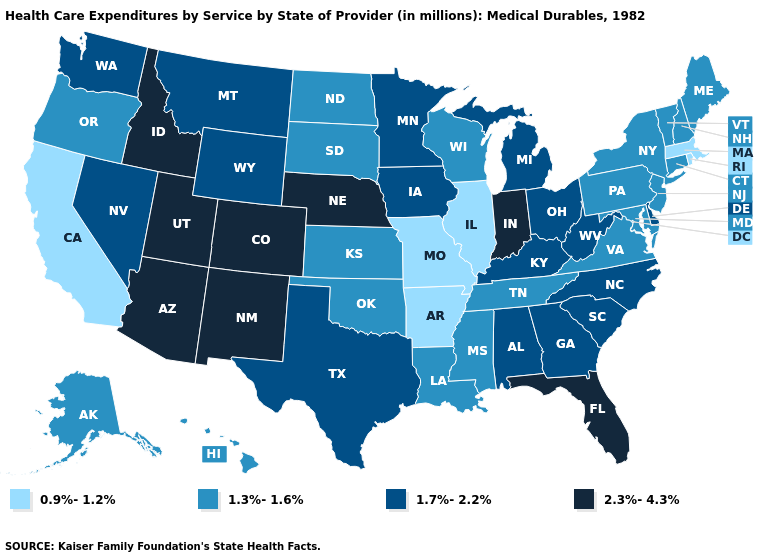Does Utah have a higher value than Nebraska?
Answer briefly. No. What is the value of Oklahoma?
Quick response, please. 1.3%-1.6%. Among the states that border Wisconsin , which have the highest value?
Concise answer only. Iowa, Michigan, Minnesota. Does Missouri have the lowest value in the MidWest?
Write a very short answer. Yes. What is the highest value in the Northeast ?
Quick response, please. 1.3%-1.6%. Is the legend a continuous bar?
Concise answer only. No. Does Alaska have the same value as New Hampshire?
Keep it brief. Yes. Does Montana have a lower value than Nebraska?
Be succinct. Yes. Does Colorado have the highest value in the USA?
Give a very brief answer. Yes. What is the lowest value in the West?
Give a very brief answer. 0.9%-1.2%. Does Utah have the highest value in the USA?
Concise answer only. Yes. What is the value of New Hampshire?
Concise answer only. 1.3%-1.6%. Name the states that have a value in the range 1.7%-2.2%?
Answer briefly. Alabama, Delaware, Georgia, Iowa, Kentucky, Michigan, Minnesota, Montana, Nevada, North Carolina, Ohio, South Carolina, Texas, Washington, West Virginia, Wyoming. Name the states that have a value in the range 2.3%-4.3%?
Be succinct. Arizona, Colorado, Florida, Idaho, Indiana, Nebraska, New Mexico, Utah. What is the lowest value in states that border Colorado?
Short answer required. 1.3%-1.6%. 